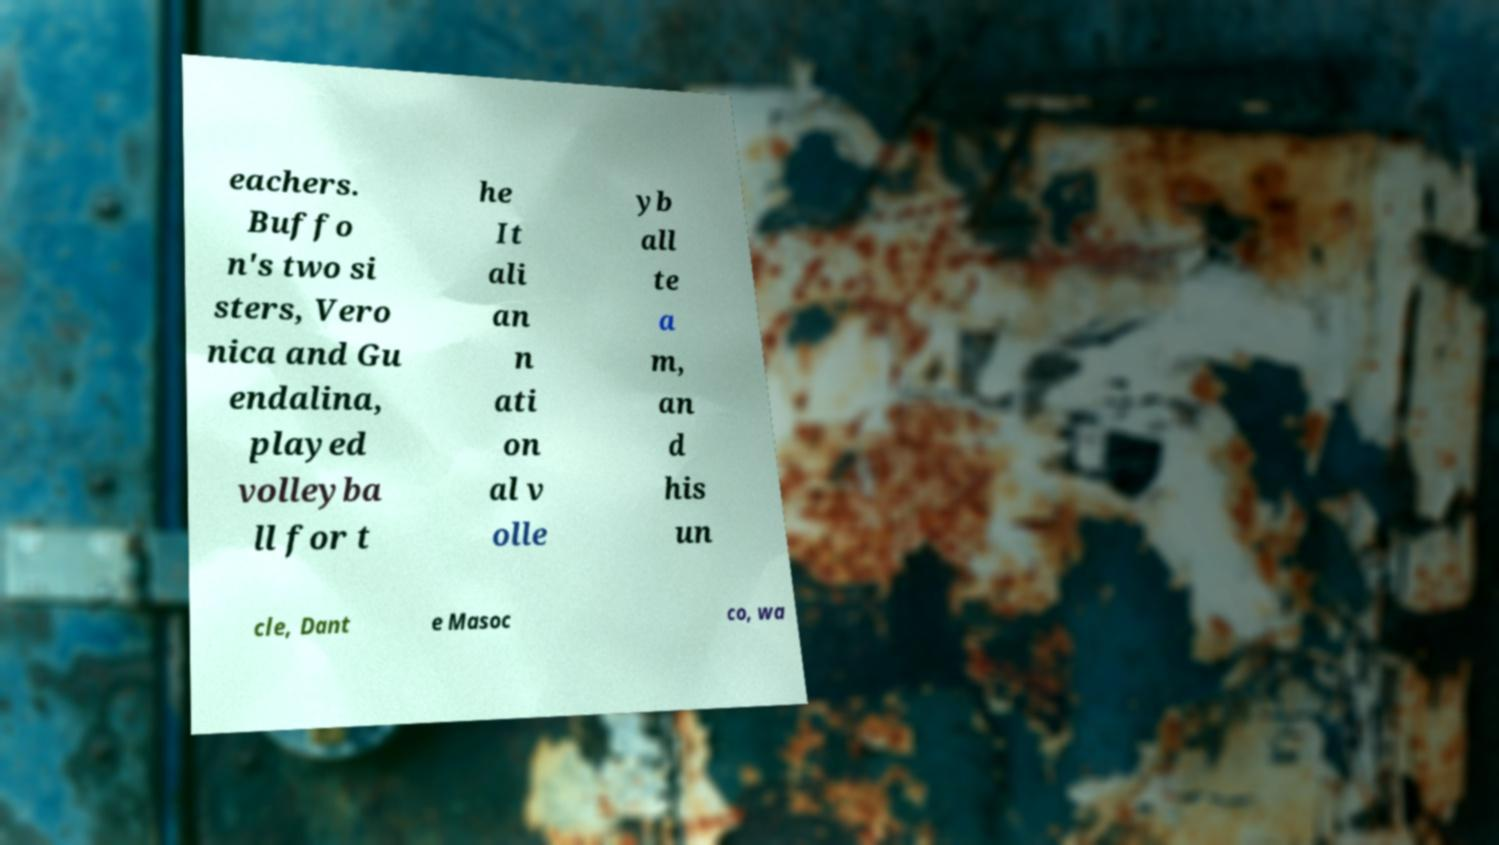Could you extract and type out the text from this image? eachers. Buffo n's two si sters, Vero nica and Gu endalina, played volleyba ll for t he It ali an n ati on al v olle yb all te a m, an d his un cle, Dant e Masoc co, wa 